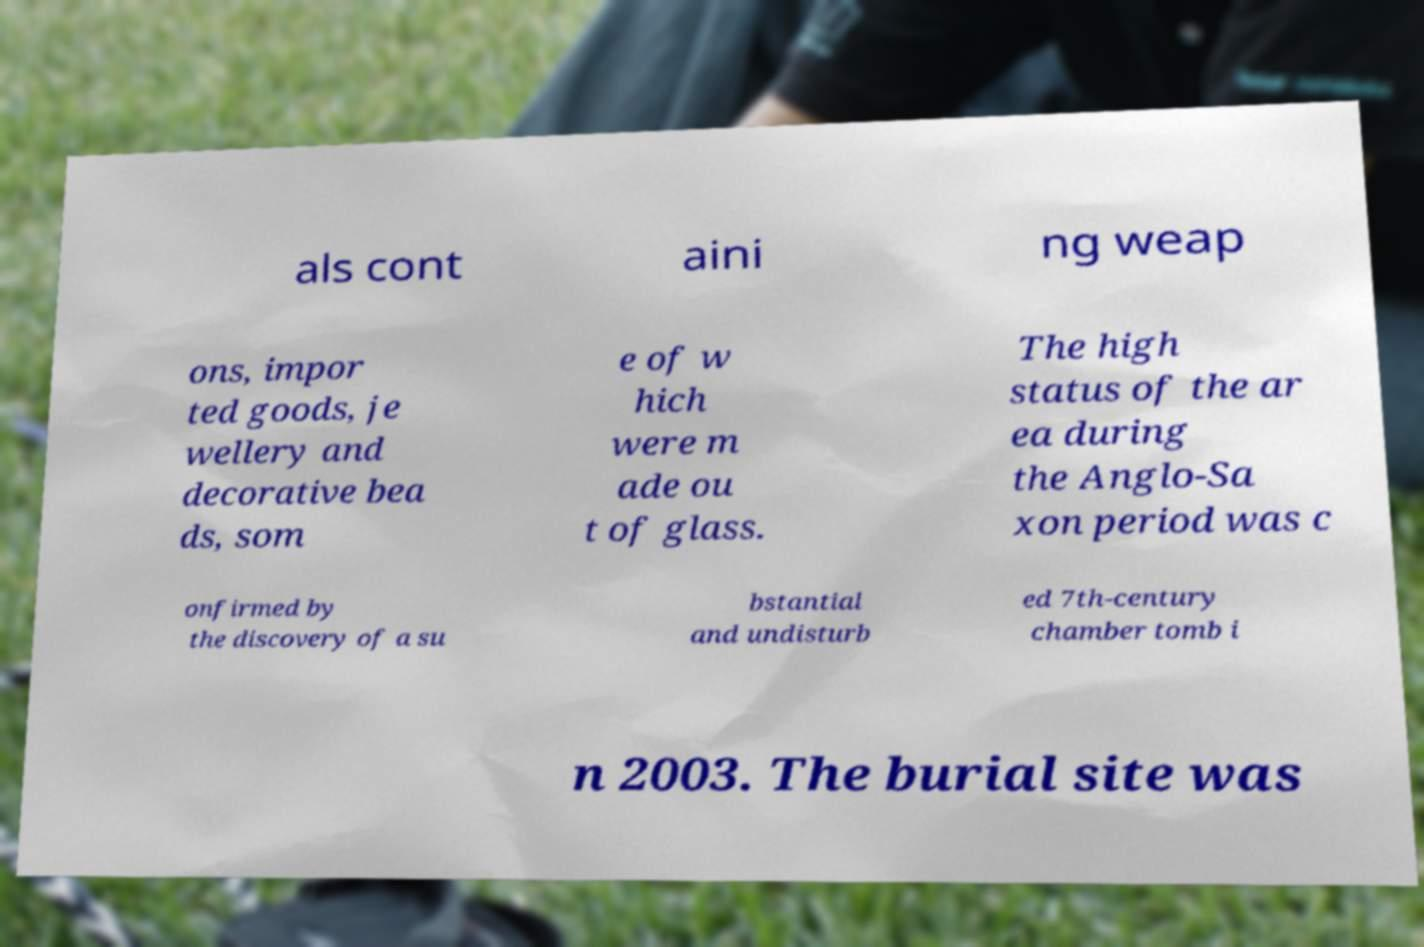For documentation purposes, I need the text within this image transcribed. Could you provide that? als cont aini ng weap ons, impor ted goods, je wellery and decorative bea ds, som e of w hich were m ade ou t of glass. The high status of the ar ea during the Anglo-Sa xon period was c onfirmed by the discovery of a su bstantial and undisturb ed 7th-century chamber tomb i n 2003. The burial site was 